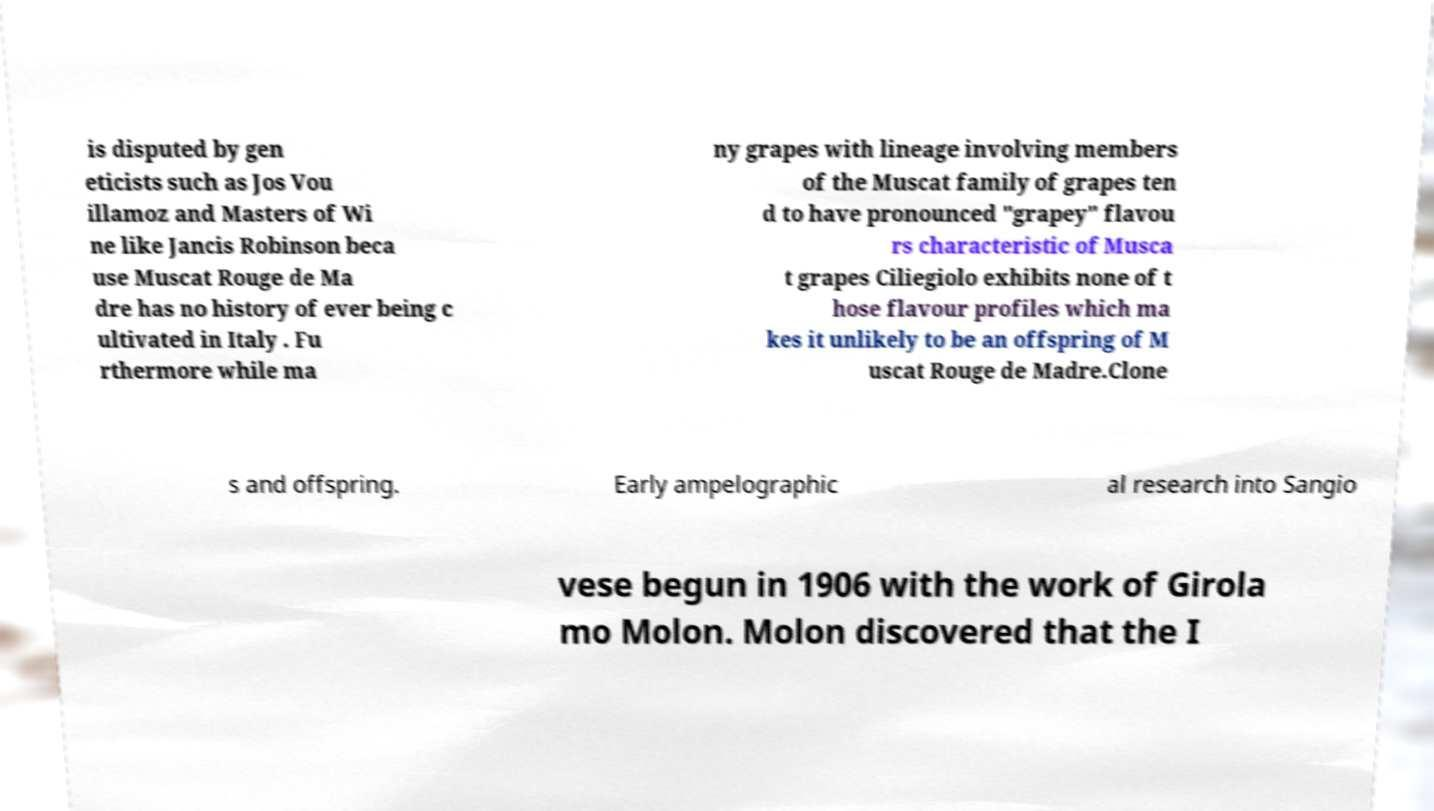Could you assist in decoding the text presented in this image and type it out clearly? is disputed by gen eticists such as Jos Vou illamoz and Masters of Wi ne like Jancis Robinson beca use Muscat Rouge de Ma dre has no history of ever being c ultivated in Italy . Fu rthermore while ma ny grapes with lineage involving members of the Muscat family of grapes ten d to have pronounced "grapey" flavou rs characteristic of Musca t grapes Ciliegiolo exhibits none of t hose flavour profiles which ma kes it unlikely to be an offspring of M uscat Rouge de Madre.Clone s and offspring. Early ampelographic al research into Sangio vese begun in 1906 with the work of Girola mo Molon. Molon discovered that the I 